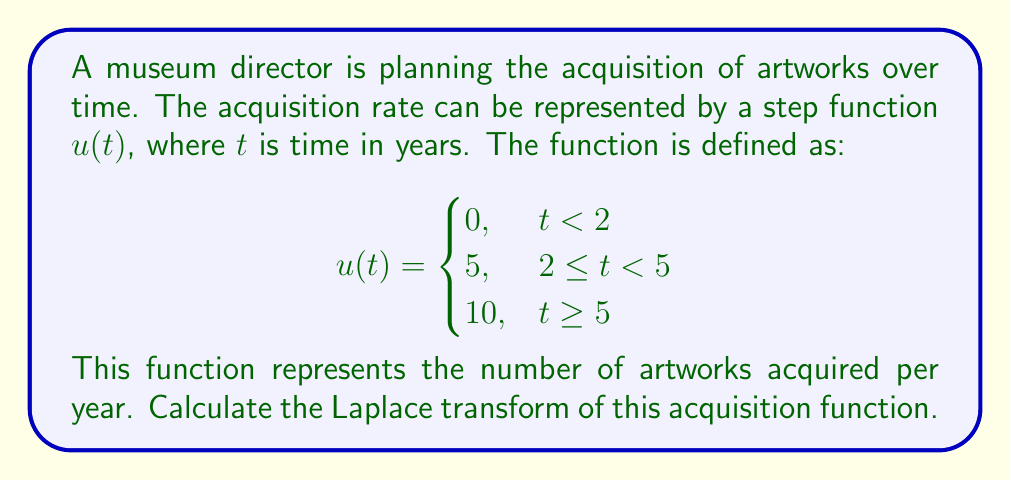Show me your answer to this math problem. To solve this problem, we need to apply the Laplace transform to the given step function. Let's break it down step by step:

1) The Laplace transform of a step function is given by:

   $$\mathcal{L}\{u(t-a)\} = \frac{e^{-as}}{s}$$

   where $a$ is the time delay and $s$ is the Laplace variable.

2) Our function consists of two step functions:
   - One starting at $t=2$ with amplitude 5
   - Another starting at $t=5$ with amplitude 5 (to reach a total of 10)

3) Let's call the Laplace transform of our function $U(s)$. We can write it as:

   $$U(s) = 5\mathcal{L}\{u(t-2)\} + 5\mathcal{L}\{u(t-5)\}$$

4) Applying the Laplace transform formula for each step:

   $$U(s) = 5\cdot\frac{e^{-2s}}{s} + 5\cdot\frac{e^{-5s}}{s}$$

5) Factoring out $\frac{5}{s}$:

   $$U(s) = \frac{5}{s}(e^{-2s} + e^{-5s})$$

This is the Laplace transform of the given acquisition function.
Answer: $$U(s) = \frac{5}{s}(e^{-2s} + e^{-5s})$$ 